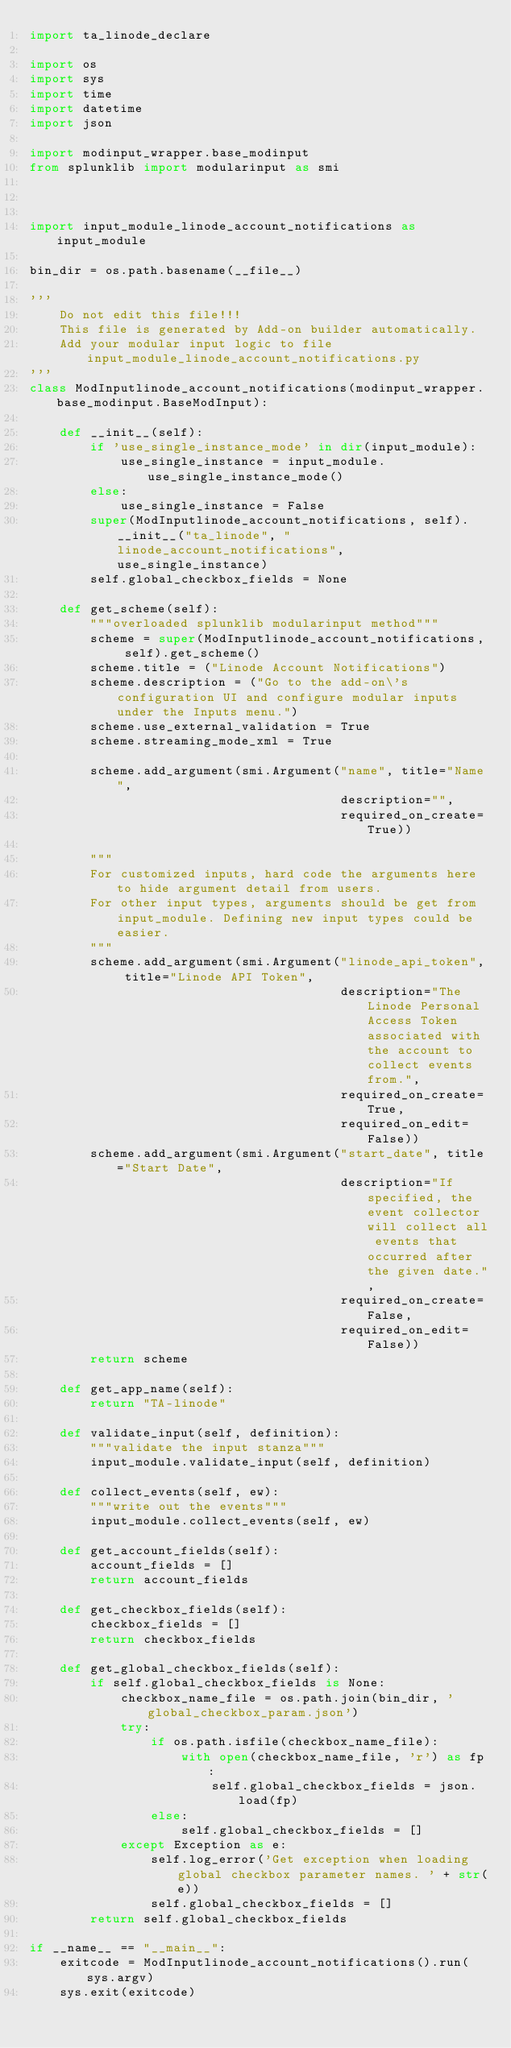<code> <loc_0><loc_0><loc_500><loc_500><_Python_>import ta_linode_declare

import os
import sys
import time
import datetime
import json

import modinput_wrapper.base_modinput
from splunklib import modularinput as smi



import input_module_linode_account_notifications as input_module

bin_dir = os.path.basename(__file__)

'''
    Do not edit this file!!!
    This file is generated by Add-on builder automatically.
    Add your modular input logic to file input_module_linode_account_notifications.py
'''
class ModInputlinode_account_notifications(modinput_wrapper.base_modinput.BaseModInput):

    def __init__(self):
        if 'use_single_instance_mode' in dir(input_module):
            use_single_instance = input_module.use_single_instance_mode()
        else:
            use_single_instance = False
        super(ModInputlinode_account_notifications, self).__init__("ta_linode", "linode_account_notifications", use_single_instance)
        self.global_checkbox_fields = None

    def get_scheme(self):
        """overloaded splunklib modularinput method"""
        scheme = super(ModInputlinode_account_notifications, self).get_scheme()
        scheme.title = ("Linode Account Notifications")
        scheme.description = ("Go to the add-on\'s configuration UI and configure modular inputs under the Inputs menu.")
        scheme.use_external_validation = True
        scheme.streaming_mode_xml = True

        scheme.add_argument(smi.Argument("name", title="Name",
                                         description="",
                                         required_on_create=True))

        """
        For customized inputs, hard code the arguments here to hide argument detail from users.
        For other input types, arguments should be get from input_module. Defining new input types could be easier.
        """
        scheme.add_argument(smi.Argument("linode_api_token", title="Linode API Token",
                                         description="The Linode Personal Access Token associated with the account to collect events from.",
                                         required_on_create=True,
                                         required_on_edit=False))
        scheme.add_argument(smi.Argument("start_date", title="Start Date",
                                         description="If specified, the event collector will collect all events that occurred after the given date.",
                                         required_on_create=False,
                                         required_on_edit=False))
        return scheme

    def get_app_name(self):
        return "TA-linode"

    def validate_input(self, definition):
        """validate the input stanza"""
        input_module.validate_input(self, definition)

    def collect_events(self, ew):
        """write out the events"""
        input_module.collect_events(self, ew)

    def get_account_fields(self):
        account_fields = []
        return account_fields

    def get_checkbox_fields(self):
        checkbox_fields = []
        return checkbox_fields

    def get_global_checkbox_fields(self):
        if self.global_checkbox_fields is None:
            checkbox_name_file = os.path.join(bin_dir, 'global_checkbox_param.json')
            try:
                if os.path.isfile(checkbox_name_file):
                    with open(checkbox_name_file, 'r') as fp:
                        self.global_checkbox_fields = json.load(fp)
                else:
                    self.global_checkbox_fields = []
            except Exception as e:
                self.log_error('Get exception when loading global checkbox parameter names. ' + str(e))
                self.global_checkbox_fields = []
        return self.global_checkbox_fields

if __name__ == "__main__":
    exitcode = ModInputlinode_account_notifications().run(sys.argv)
    sys.exit(exitcode)
</code> 